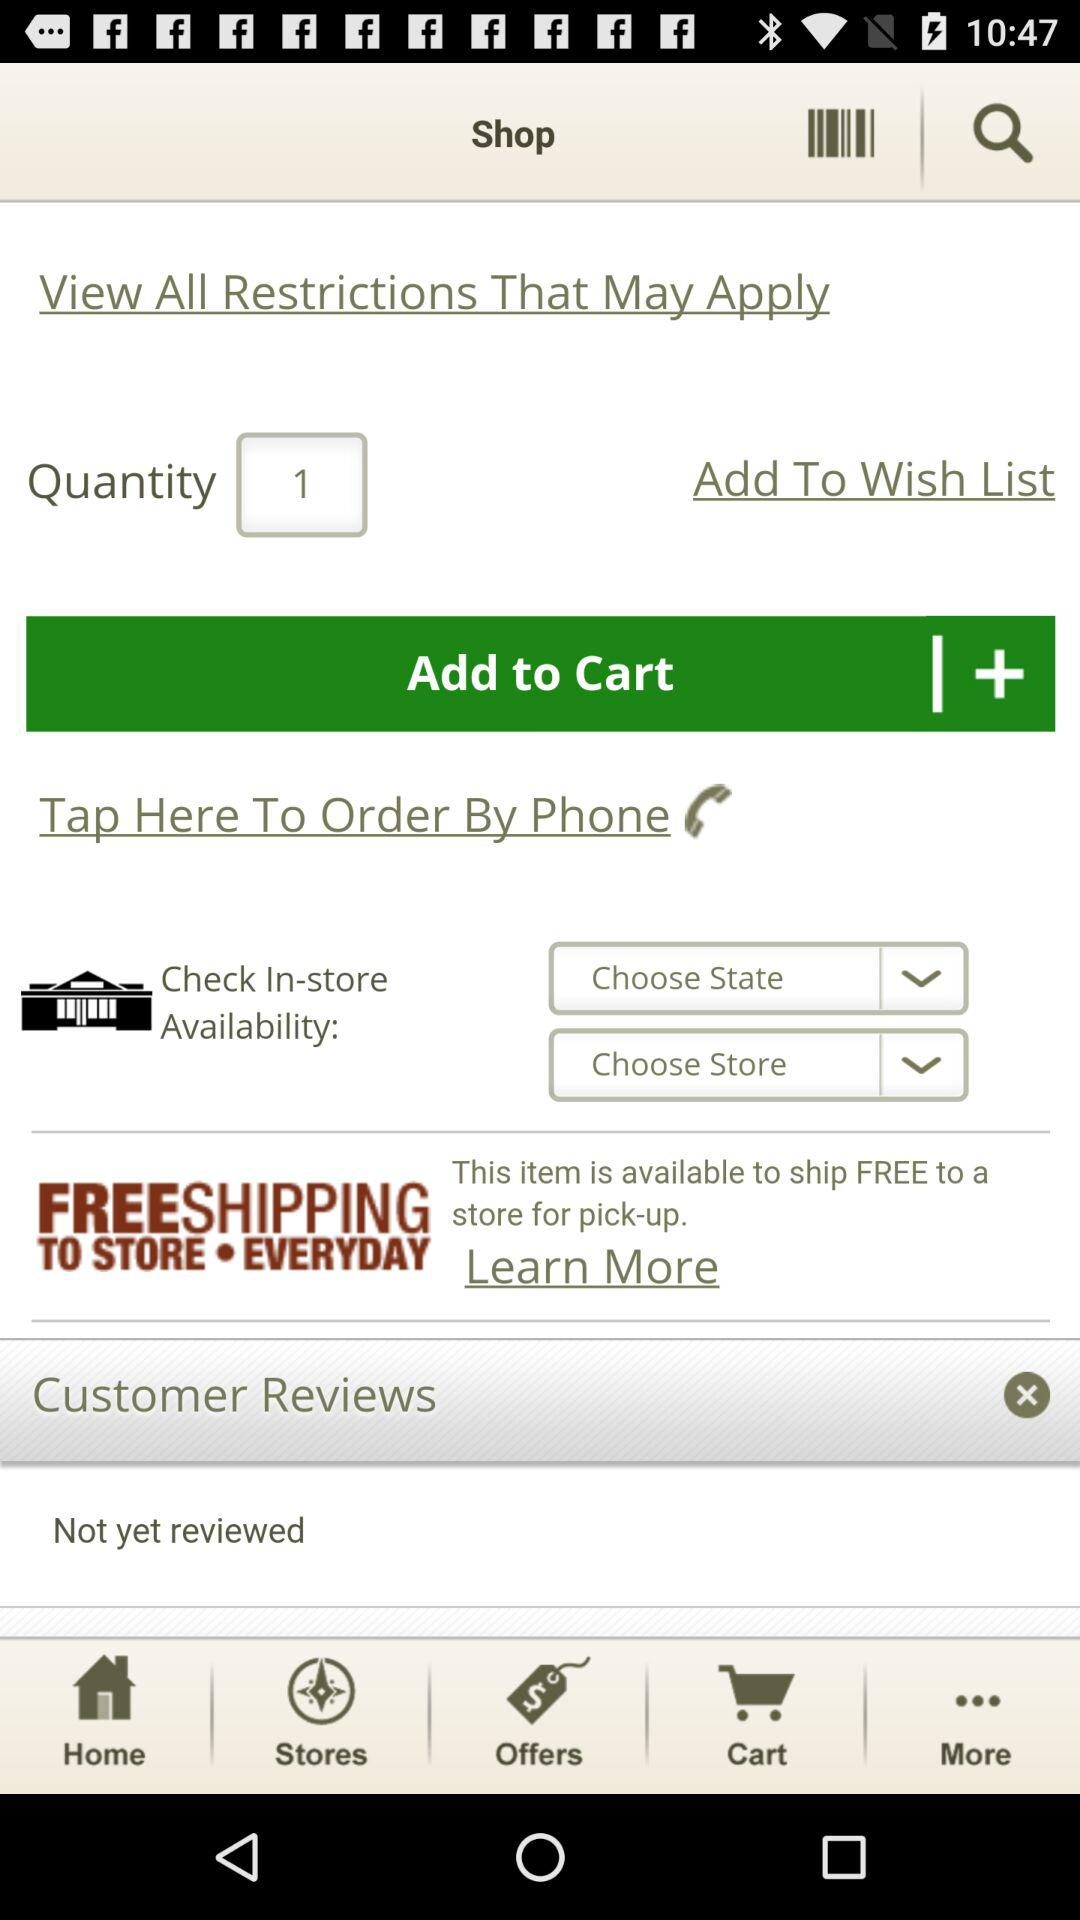What quantity is selected? The selected quantity is 1. 